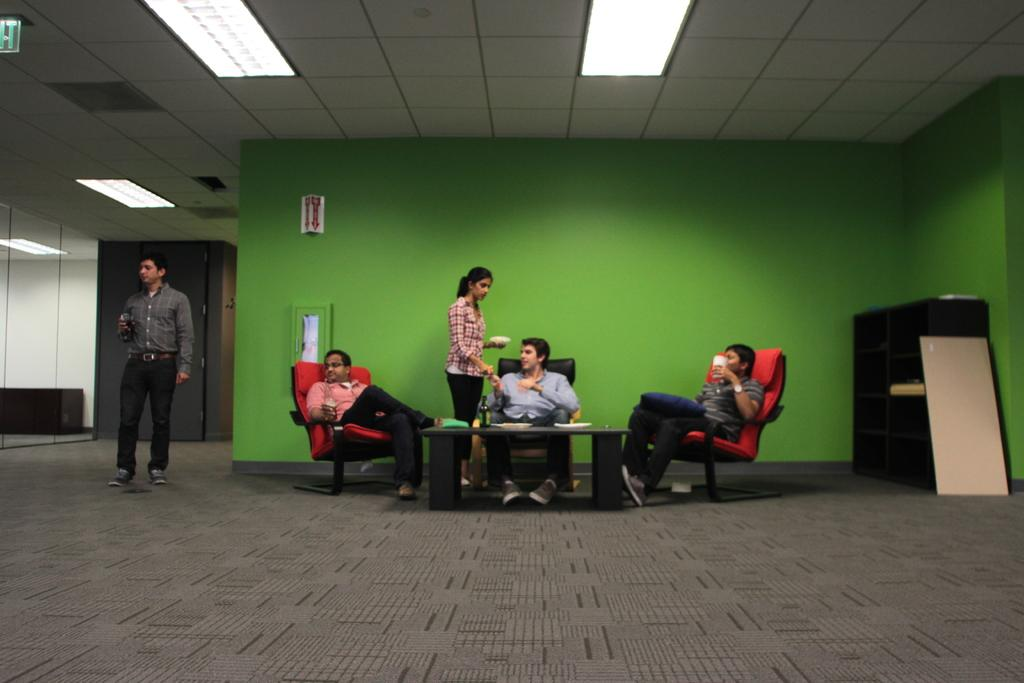How many men are seated in the image? There are three men seated in the image. How many people are standing in the image? There are two people standing in the image. What is present in the image that people might gather around? There is a table in the image. What can be seen on the table in the image? There is a bottle on the table. What type of chicken is being cooked in the kettle in the image? There is no chicken or kettle present in the image. 